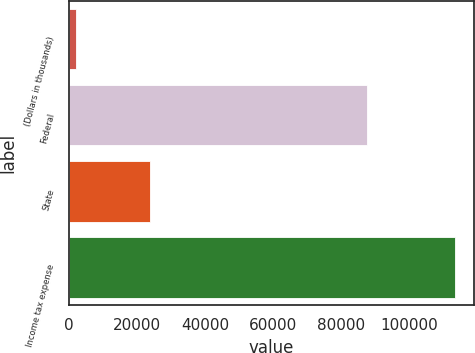Convert chart to OTSL. <chart><loc_0><loc_0><loc_500><loc_500><bar_chart><fcel>(Dollars in thousands)<fcel>Federal<fcel>State<fcel>Income tax expense<nl><fcel>2012<fcel>87635<fcel>23752<fcel>113269<nl></chart> 